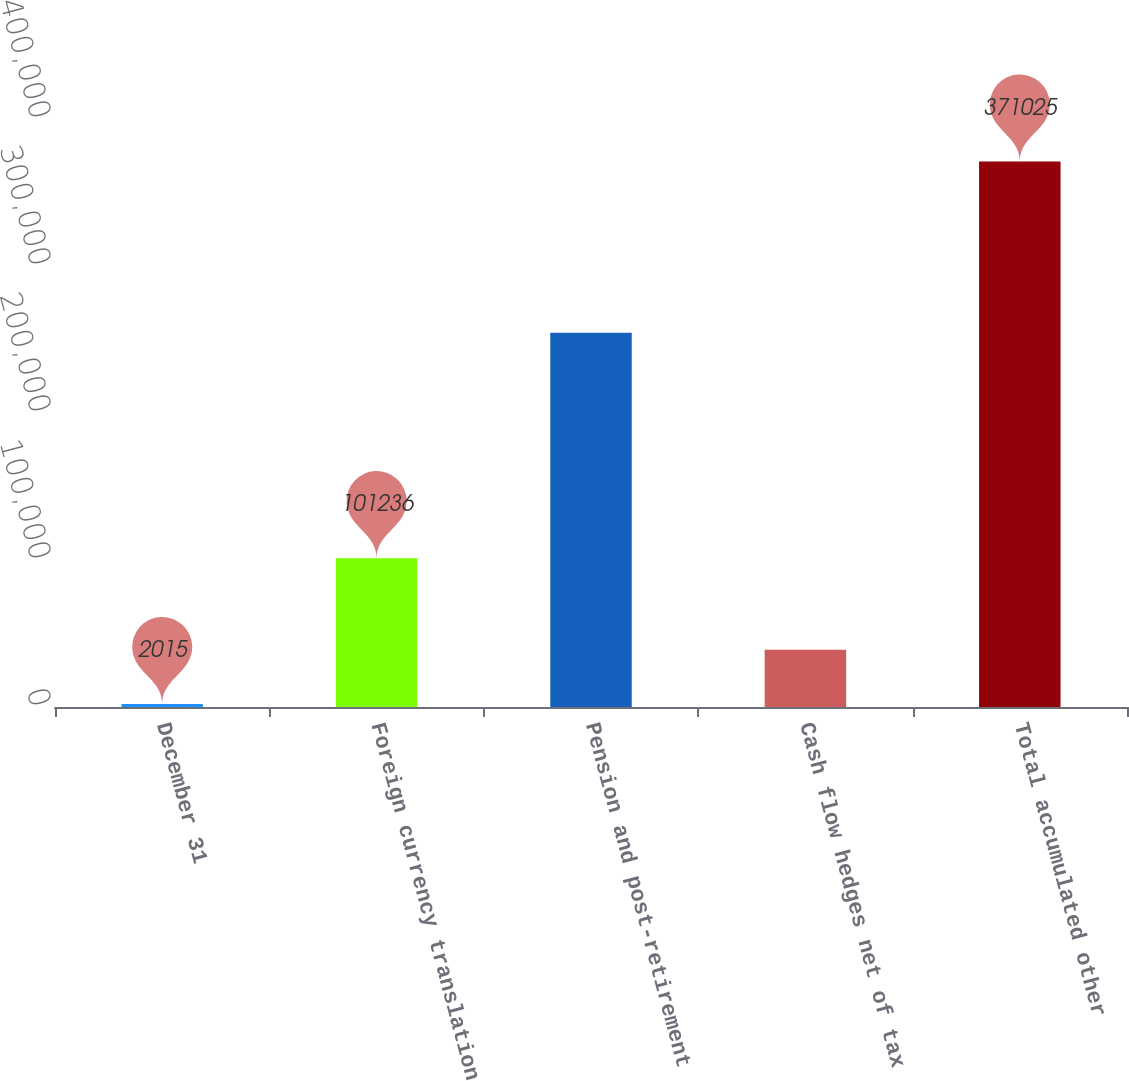Convert chart. <chart><loc_0><loc_0><loc_500><loc_500><bar_chart><fcel>December 31<fcel>Foreign currency translation<fcel>Pension and post-retirement<fcel>Cash flow hedges net of tax<fcel>Total accumulated other<nl><fcel>2015<fcel>101236<fcel>254648<fcel>38916<fcel>371025<nl></chart> 